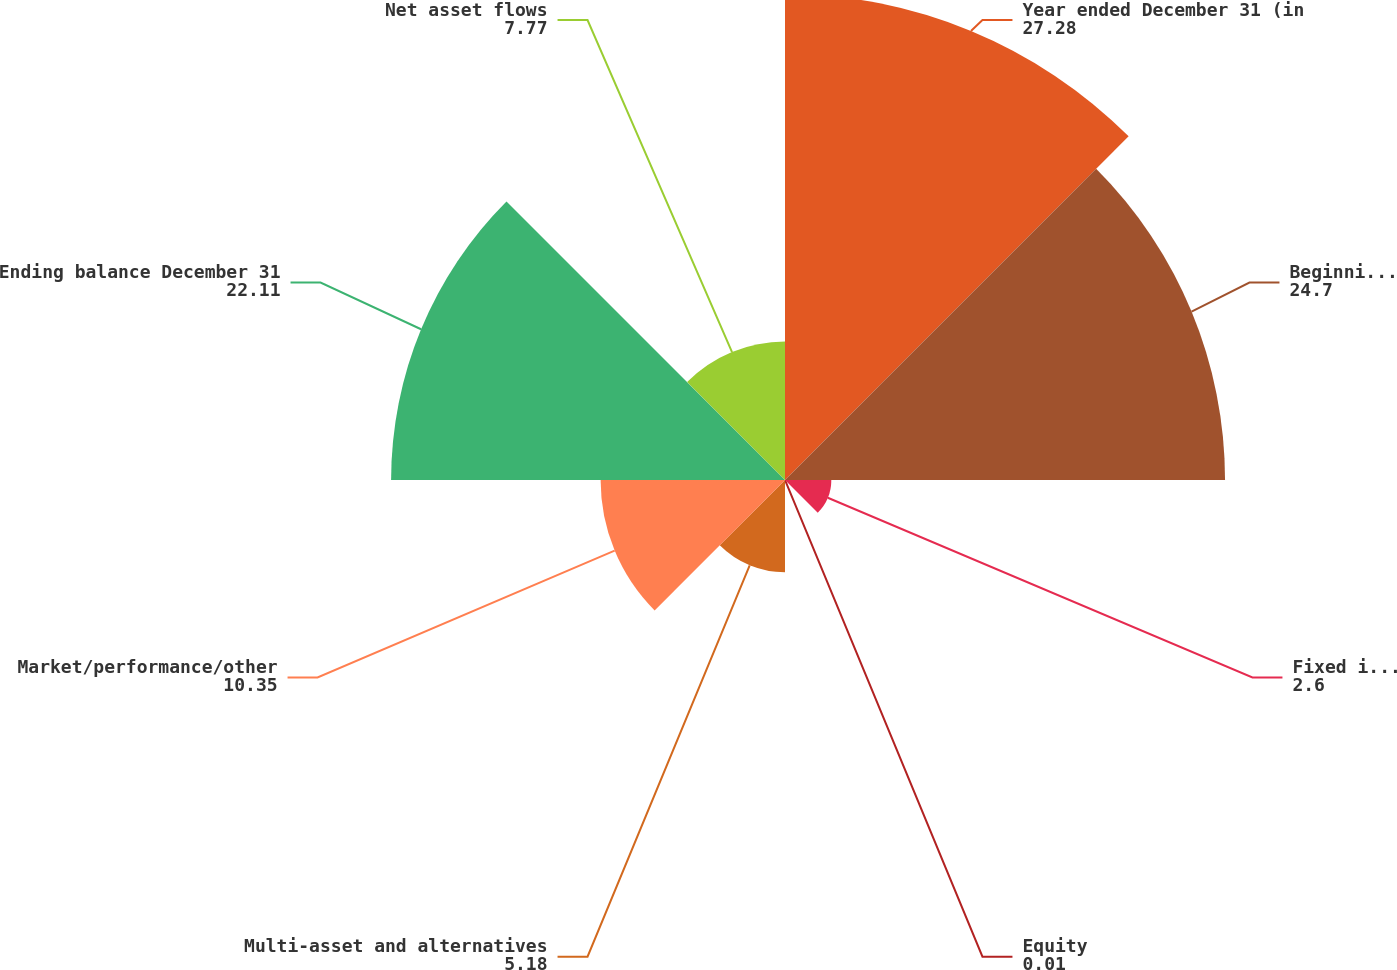Convert chart to OTSL. <chart><loc_0><loc_0><loc_500><loc_500><pie_chart><fcel>Year ended December 31 (in<fcel>Beginning balance<fcel>Fixed income<fcel>Equity<fcel>Multi-asset and alternatives<fcel>Market/performance/other<fcel>Ending balance December 31<fcel>Net asset flows<nl><fcel>27.28%<fcel>24.7%<fcel>2.6%<fcel>0.01%<fcel>5.18%<fcel>10.35%<fcel>22.11%<fcel>7.77%<nl></chart> 